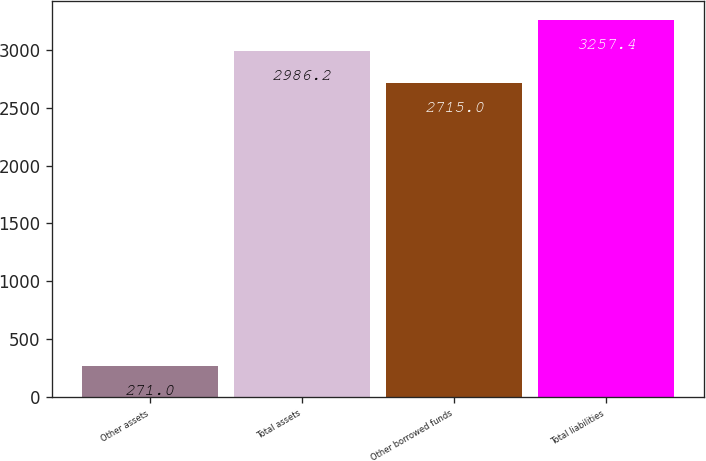Convert chart to OTSL. <chart><loc_0><loc_0><loc_500><loc_500><bar_chart><fcel>Other assets<fcel>Total assets<fcel>Other borrowed funds<fcel>Total liabilities<nl><fcel>271<fcel>2986.2<fcel>2715<fcel>3257.4<nl></chart> 